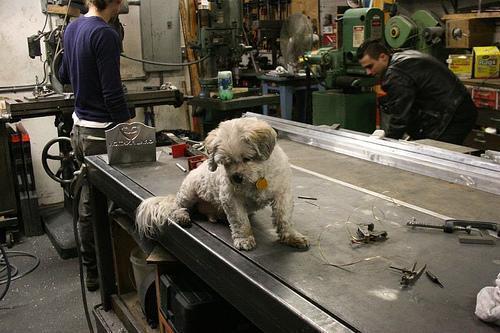What work is done in this space?
Pick the correct solution from the four options below to address the question.
Options: Coding, machine shop, cooking, typing. Machine shop. 